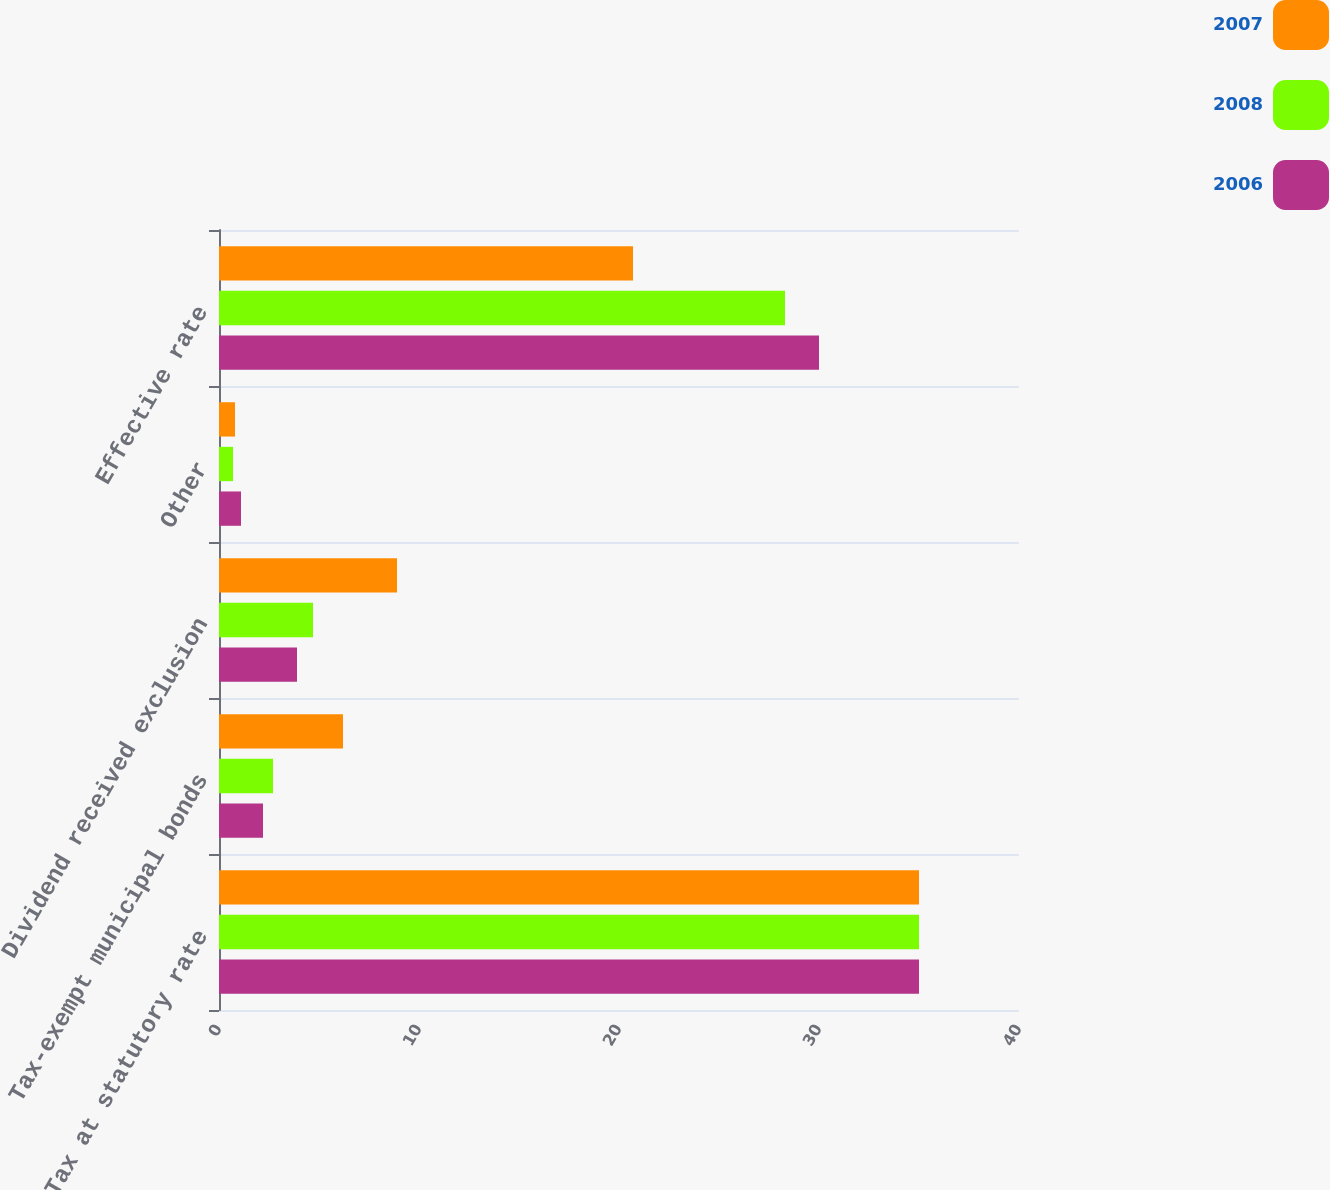Convert chart to OTSL. <chart><loc_0><loc_0><loc_500><loc_500><stacked_bar_chart><ecel><fcel>Tax at statutory rate<fcel>Tax-exempt municipal bonds<fcel>Dividend received exclusion<fcel>Other<fcel>Effective rate<nl><fcel>2007<fcel>35<fcel>6.2<fcel>8.9<fcel>0.8<fcel>20.7<nl><fcel>2008<fcel>35<fcel>2.7<fcel>4.7<fcel>0.7<fcel>28.3<nl><fcel>2006<fcel>35<fcel>2.2<fcel>3.9<fcel>1.1<fcel>30<nl></chart> 